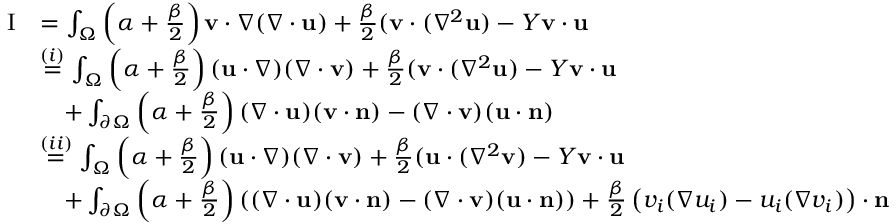<formula> <loc_0><loc_0><loc_500><loc_500>\begin{array} { r l } { I } & { = \int _ { \Omega } \left ( \alpha + \frac { \beta } { 2 } \right ) v \cdot \nabla ( \nabla \cdot u ) + \frac { \beta } { 2 } ( v \cdot ( \nabla ^ { 2 } u ) - Y v \cdot u } \\ & { \overset { ( i ) } { = } \int _ { \Omega } \left ( \alpha + \frac { \beta } { 2 } \right ) ( u \cdot \nabla ) ( \nabla \cdot v ) + \frac { \beta } { 2 } ( v \cdot ( \nabla ^ { 2 } u ) - Y v \cdot u } \\ & { \quad + \int _ { \partial \Omega } \left ( \alpha + \frac { \beta } { 2 } \right ) ( \nabla \cdot u ) ( v \cdot n ) - ( \nabla \cdot v ) ( u \cdot n ) } \\ & { \overset { ( i i ) } { = } \int _ { \Omega } \left ( \alpha + \frac { \beta } { 2 } \right ) ( u \cdot \nabla ) ( \nabla \cdot v ) + \frac { \beta } { 2 } ( u \cdot ( \nabla ^ { 2 } v ) - Y v \cdot u } \\ & { \quad + \int _ { \partial \Omega } \left ( \alpha + \frac { \beta } { 2 } \right ) \left ( ( \nabla \cdot u ) ( v \cdot n ) - ( \nabla \cdot v ) ( u \cdot n ) \right ) + \frac { \beta } { 2 } \left ( v _ { i } ( \nabla u _ { i } ) - u _ { i } ( \nabla v _ { i } ) \right ) \cdot n } \end{array}</formula> 